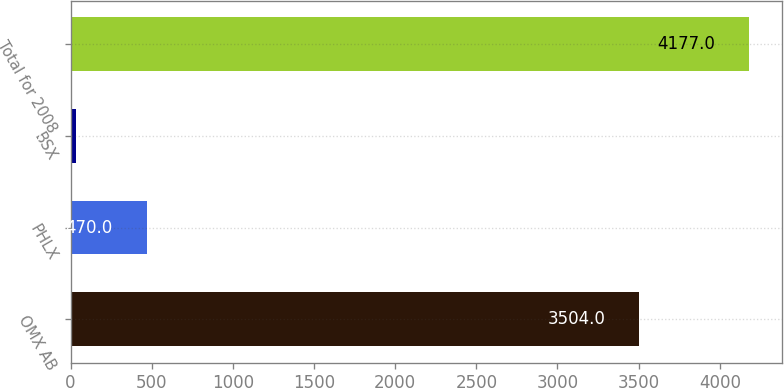Convert chart. <chart><loc_0><loc_0><loc_500><loc_500><bar_chart><fcel>OMX AB<fcel>PHLX<fcel>BSX<fcel>Total for 2008<nl><fcel>3504<fcel>470<fcel>35<fcel>4177<nl></chart> 